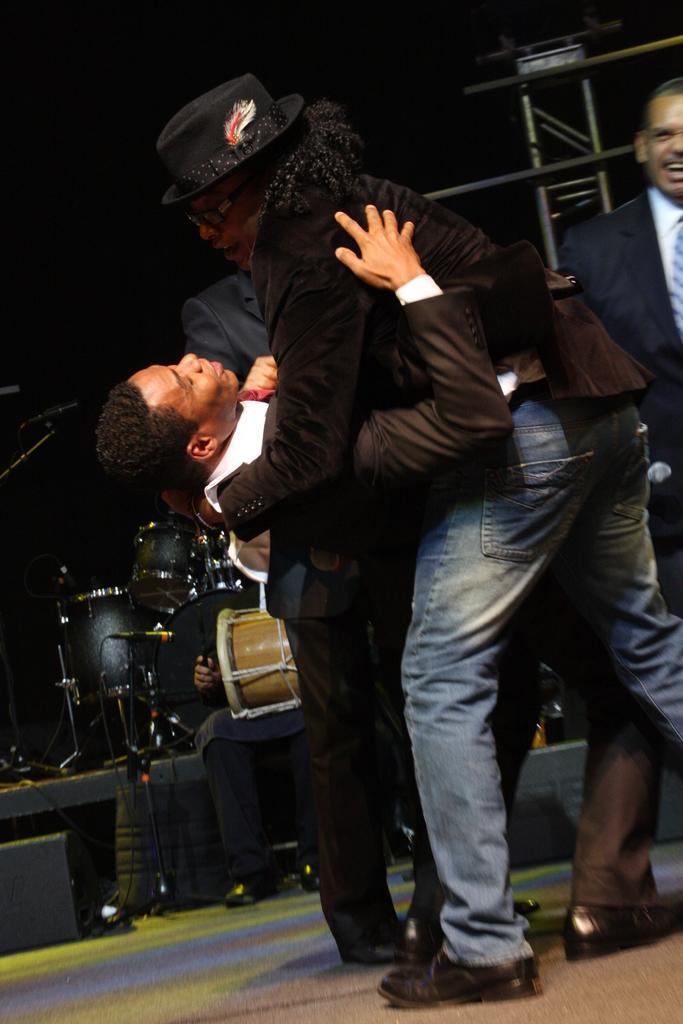How would you summarize this image in a sentence or two? This picture shows four men standing on the dais and a person bending back. 